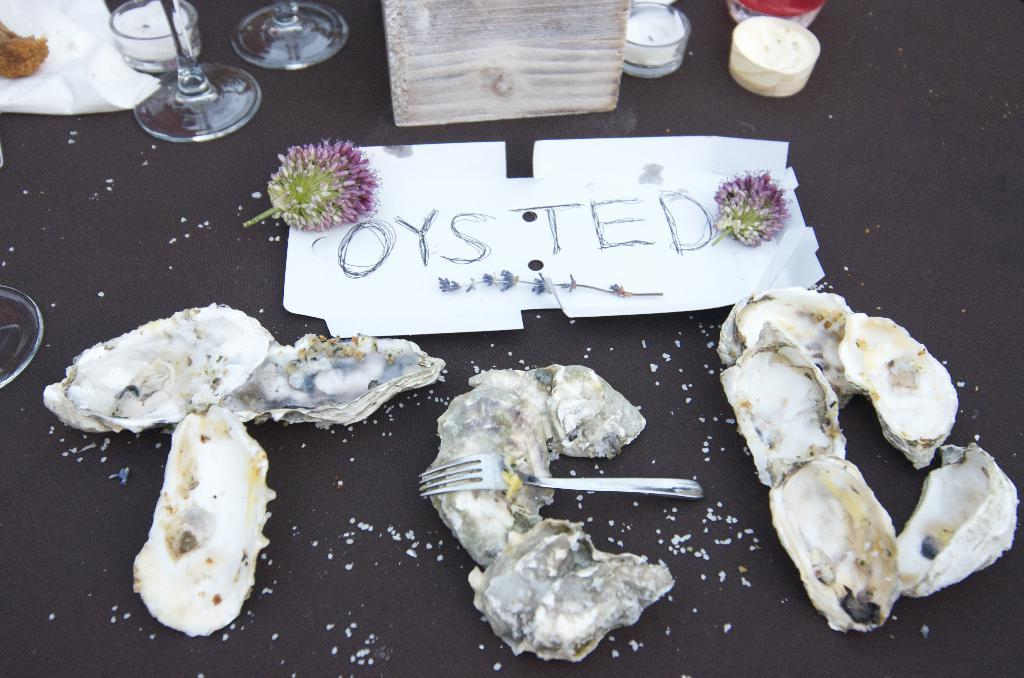What types of items can be seen in the image? There are food items, a fork, flowers, text, a plant, glasses, and a tissue in the image. Can you describe the plant in the image? The plant is on a white object. What other objects are present on a black surface? There are other objects on a black surface, but their specific details are not mentioned in the facts. What might be used for eating the food items in the image? The fork in the image can be used for eating the food items. What type of flag is visible in the image? There is no flag present in the image. What is the rate of the clam's growth in the image? There is no clam present in the image, so its growth rate cannot be determined. 